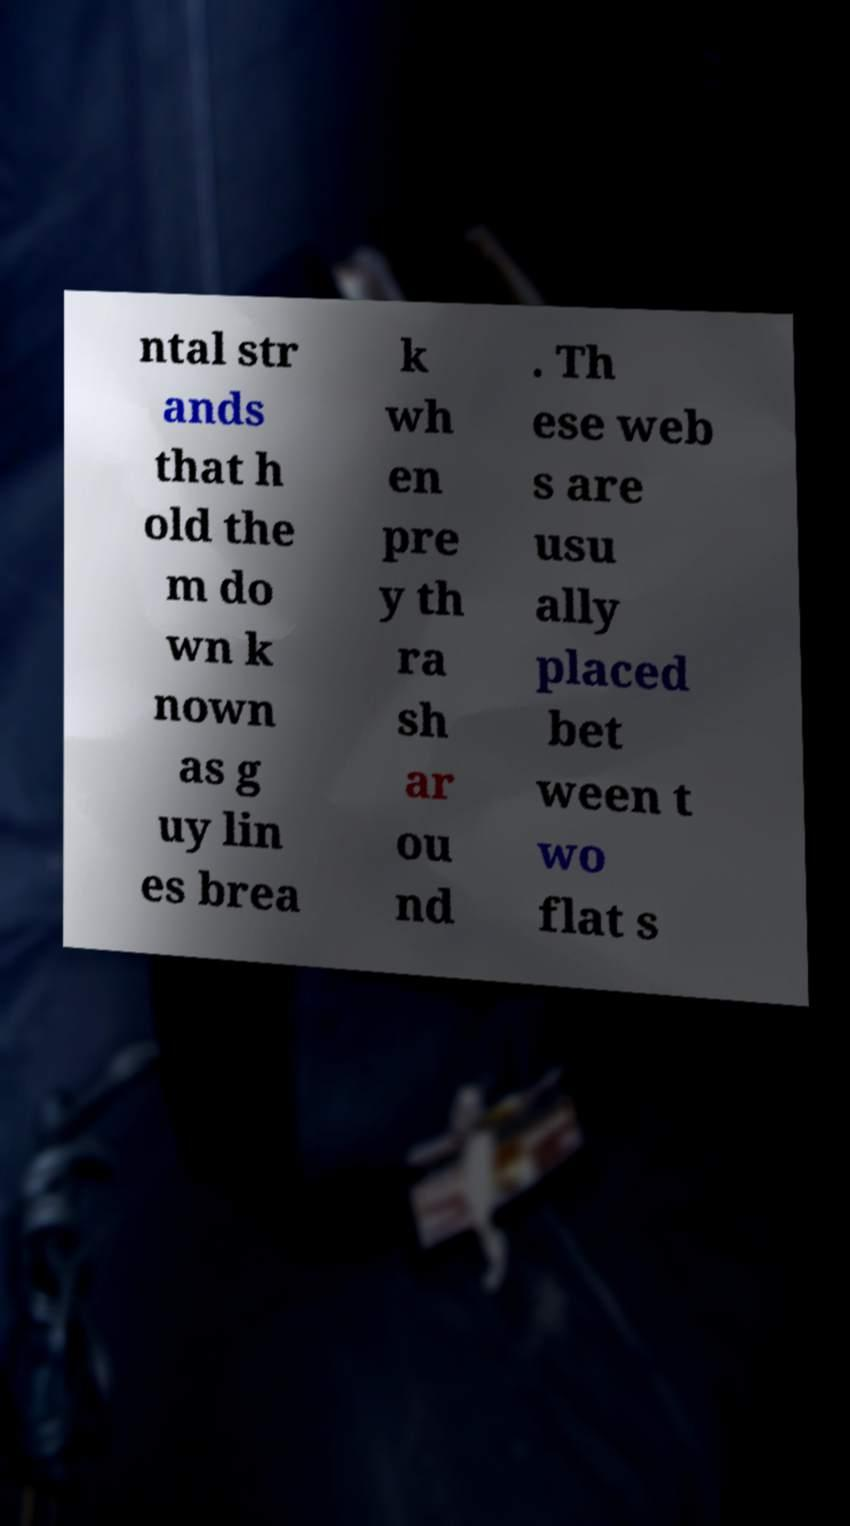For documentation purposes, I need the text within this image transcribed. Could you provide that? ntal str ands that h old the m do wn k nown as g uy lin es brea k wh en pre y th ra sh ar ou nd . Th ese web s are usu ally placed bet ween t wo flat s 